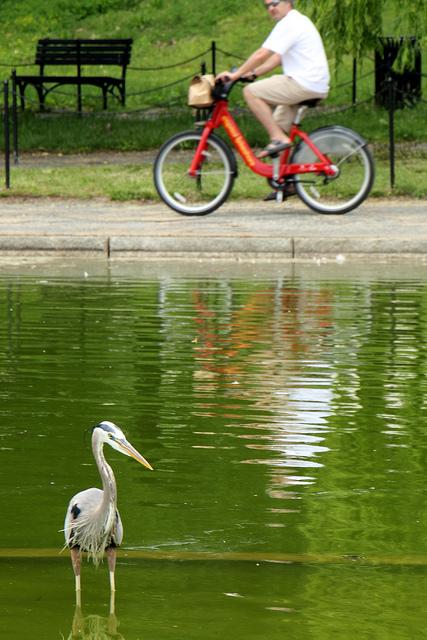At What location is the biker riding by the bird? Please explain your reasoning. park. This is a place where children play, adults can walk, and most of the time have small ponds with ducks. 